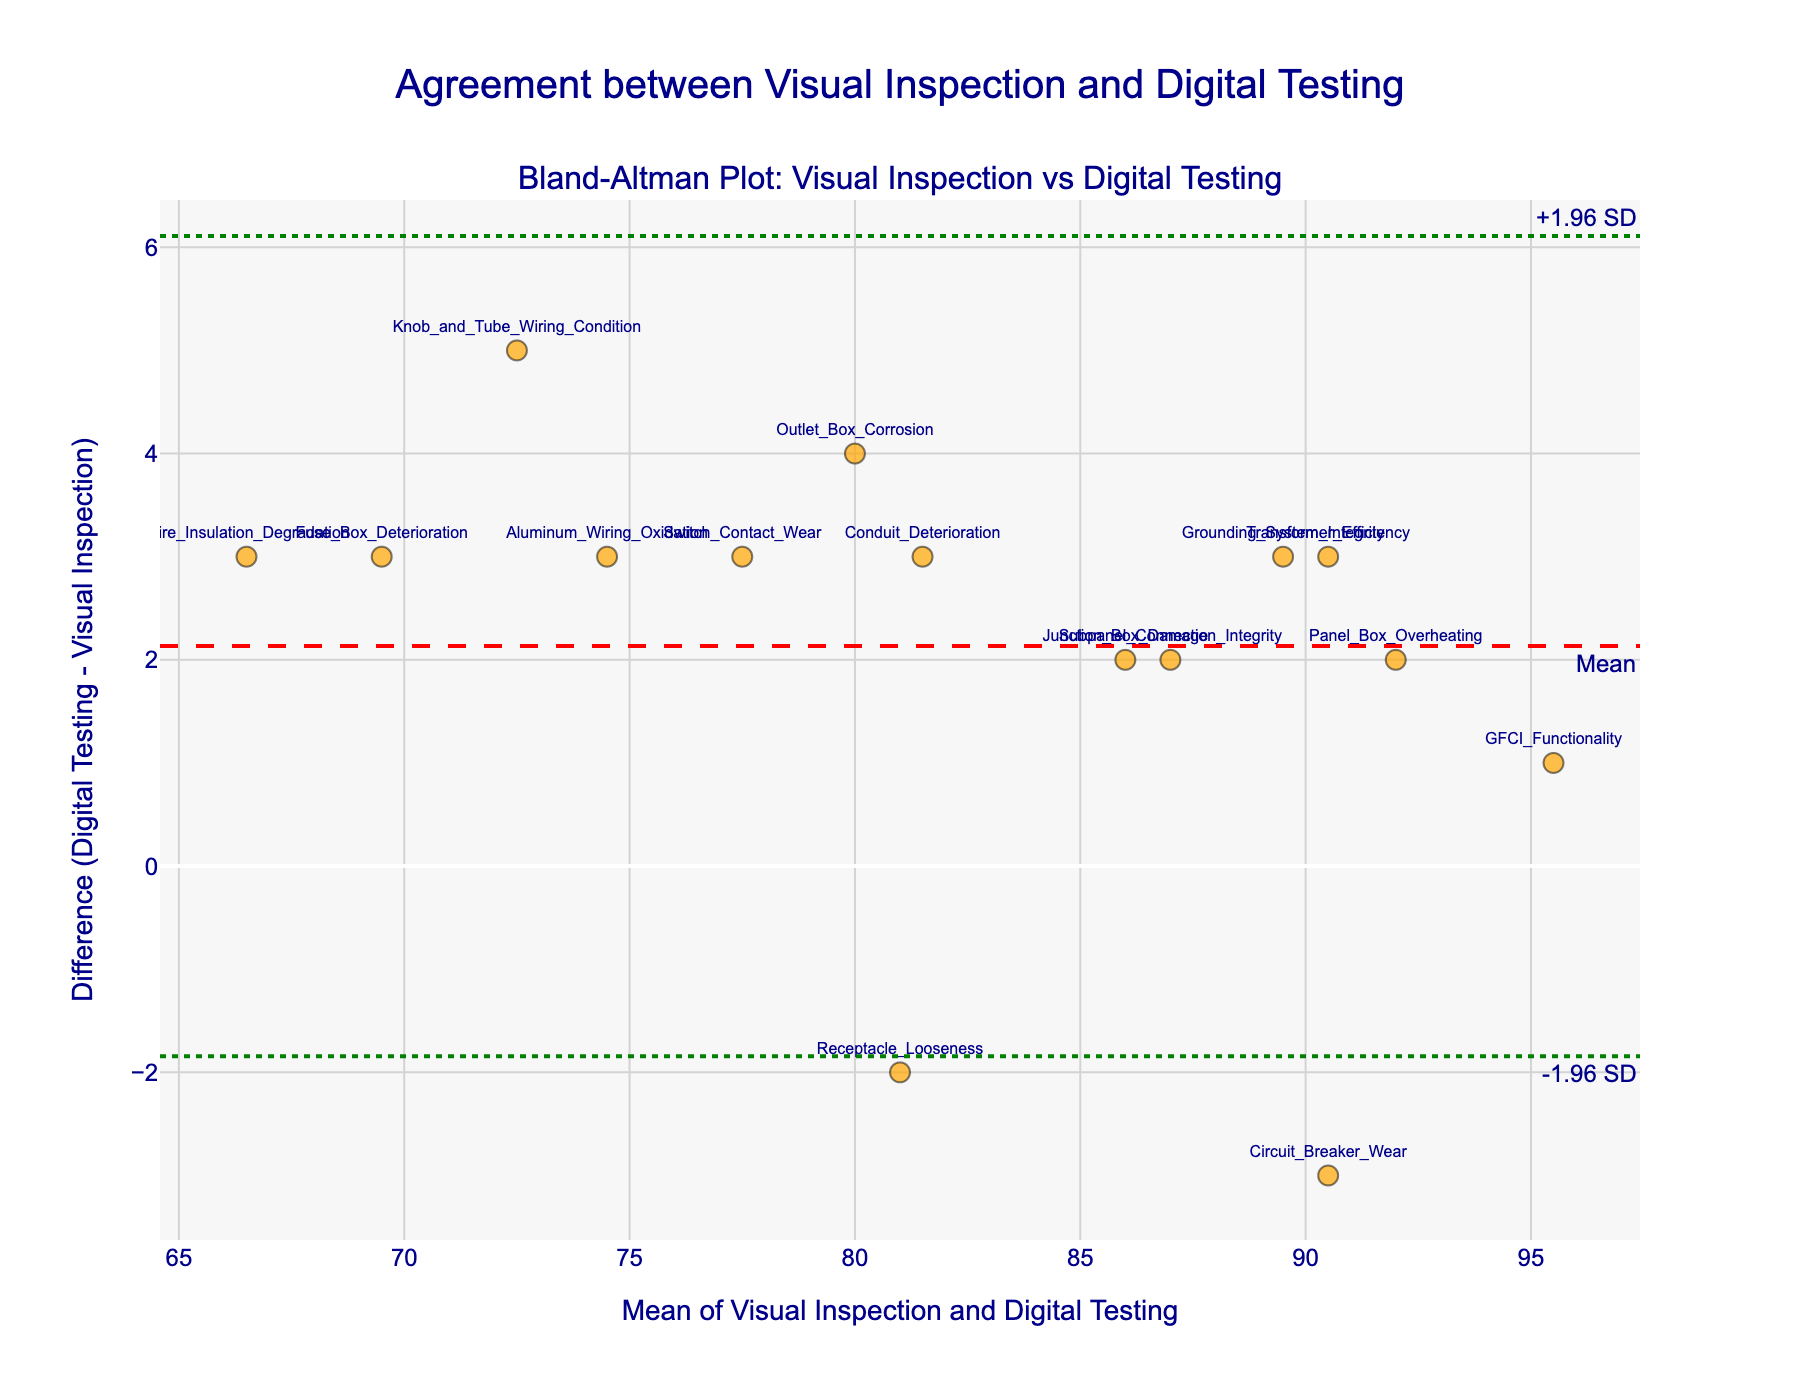How many data points are there in the plot? There are 15 labels/text annotations visible in the figure, each corresponding to a different electrical component. These represent the data points.
Answer: 15 What's the title of the figure? The title is displayed at the top of the figure and reads "Agreement between Visual Inspection and Digital Testing."
Answer: Agreement between Visual Inspection and Digital Testing What's the range of the y-axis in the plot? The y-axis range can be observed from the plot's gridlines, extending approximately from -5 to 5.
Answer: -5 to 5 What is the mean difference between visual inspection and digital testing methods? Analyzing the red dashed horizontal line and the annotation that reads "Mean," we can see that the mean difference is 1.6.
Answer: 1.6 Which component shows the largest positive difference between digital testing and visual inspection? Observing the data points, the component "Panel Box Overheating" appears at the highest positive value, with a difference of 2.
Answer: Panel Box Overheating What are the upper and lower limits of agreement (LoA)? The upper and lower limits of agreement are marked by green dotted lines, with annotations at approximately +3.74 (upper LoA) and -0.54 (lower LoA).
Answer: +3.74 and -0.54 What's the average of the mean values for "Outlet Box Corrosion" and "Wire Insulation Degradation"? The mean values of both components are (78 + 82)/2 = 80 and (65 + 68)/2 = 66.5 respectively. The average of these means is (80 + 66.5)/2 = 73.25.
Answer: 73.25 How many data points fall outside the limits of agreement? By examining the plot, all data points lie within the upper and lower limits of agreement (between -0.54 and +3.74). Thus, there are 0 data points outside the limits.
Answer: 0 Which method tends to give higher results for "Receptacle Looseness," visual inspection or digital testing? For "Receptacle Looseness," the data point has a negative y-value, indicating that visual inspection results are higher than digital testing results.
Answer: Visual inspection What can be said about the agreement between the two methods based on this plot? Since the majority (all) data points lie within the limits of agreement and the mean difference is close to zero, the plot indicates good agreement between the two methods.
Answer: Good agreement 